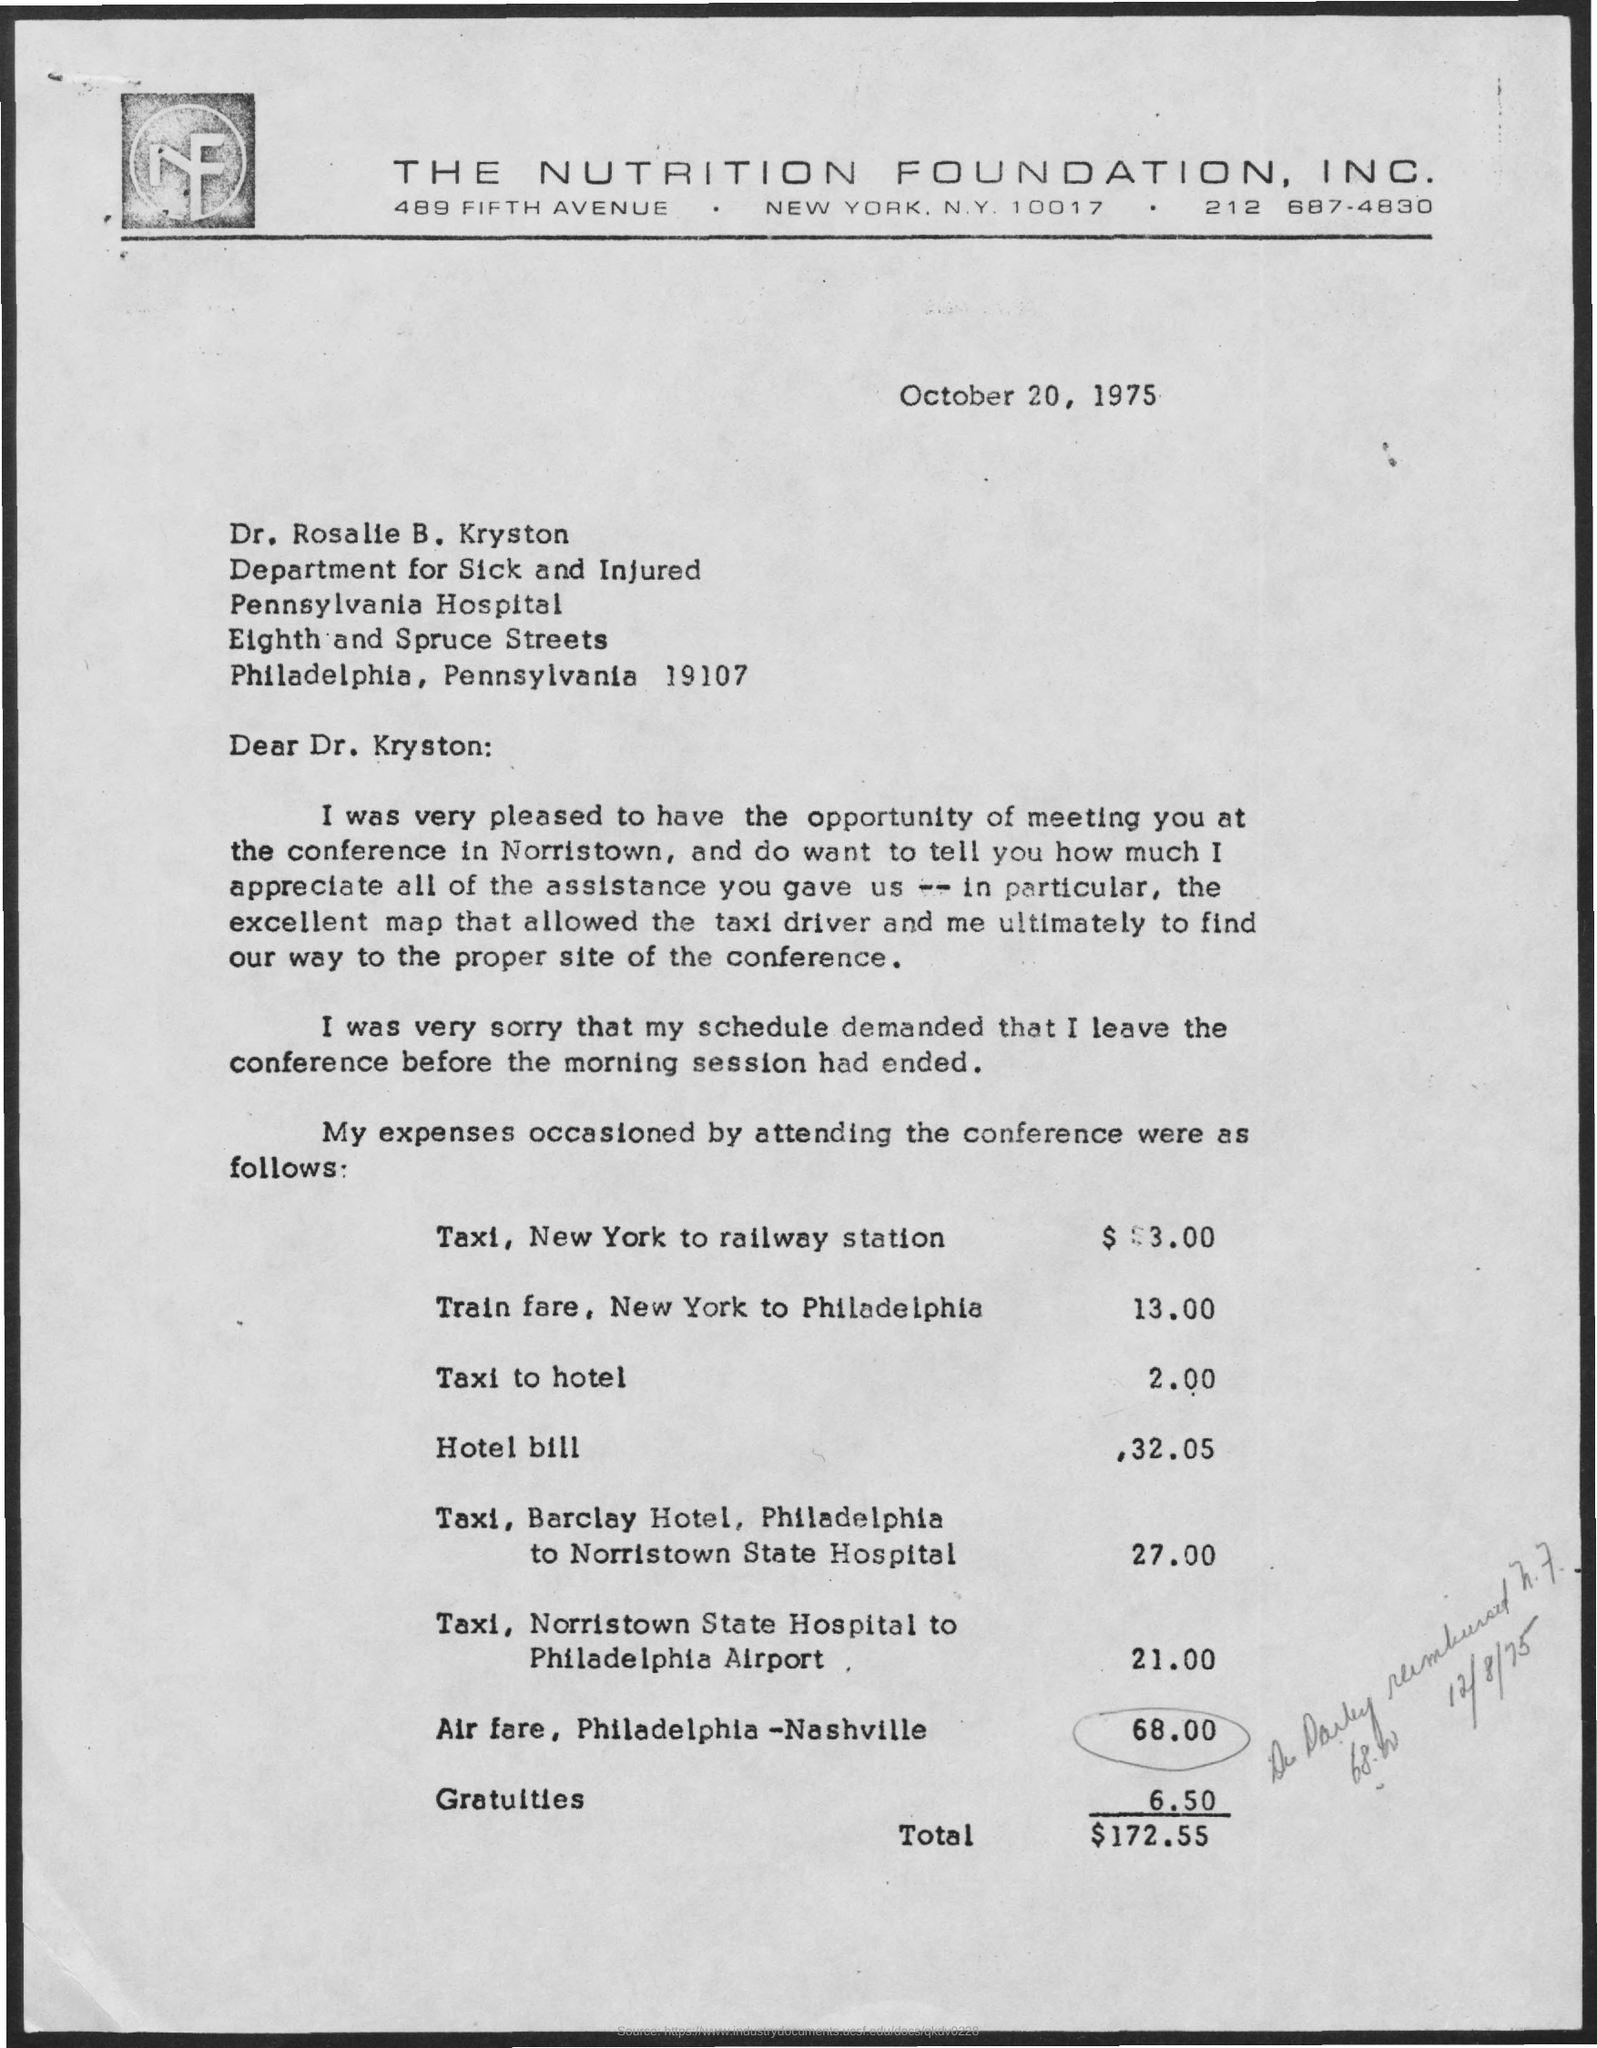Specify some key components in this picture. The letter, dated October 20, 1975, indicates that... The total amount is $172.55. The person to whom this letter is addressed is Dr. Rosalie B. Kryston. The taxi fare from New York to the railway station is $3.00. The taxi fare to the hotel is 2.00. 